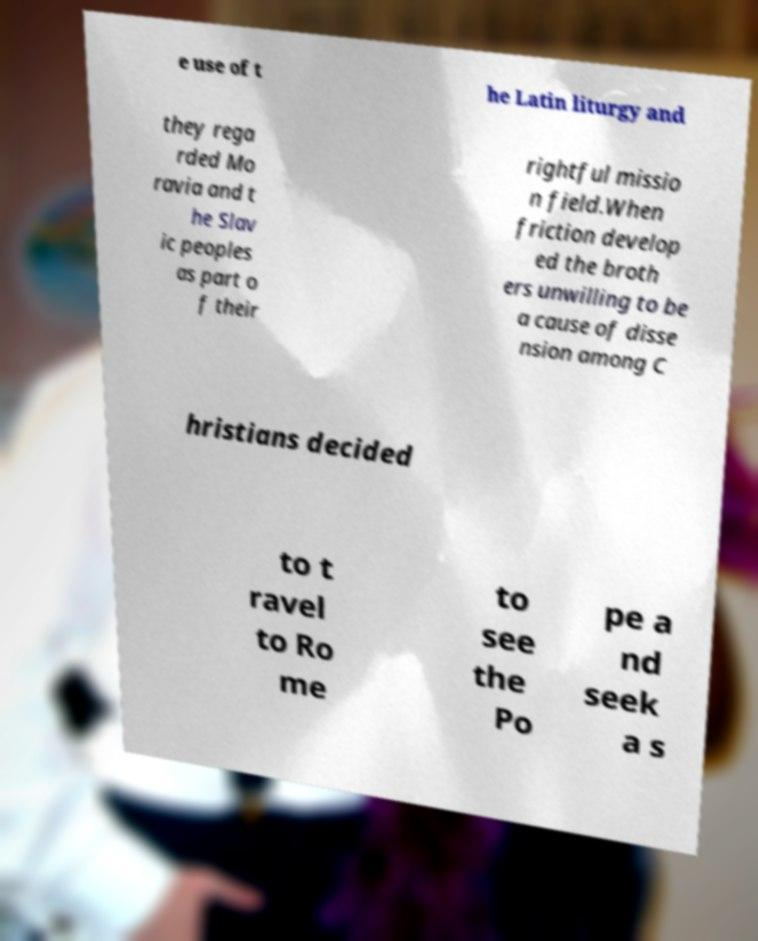Can you read and provide the text displayed in the image?This photo seems to have some interesting text. Can you extract and type it out for me? e use of t he Latin liturgy and they rega rded Mo ravia and t he Slav ic peoples as part o f their rightful missio n field.When friction develop ed the broth ers unwilling to be a cause of disse nsion among C hristians decided to t ravel to Ro me to see the Po pe a nd seek a s 